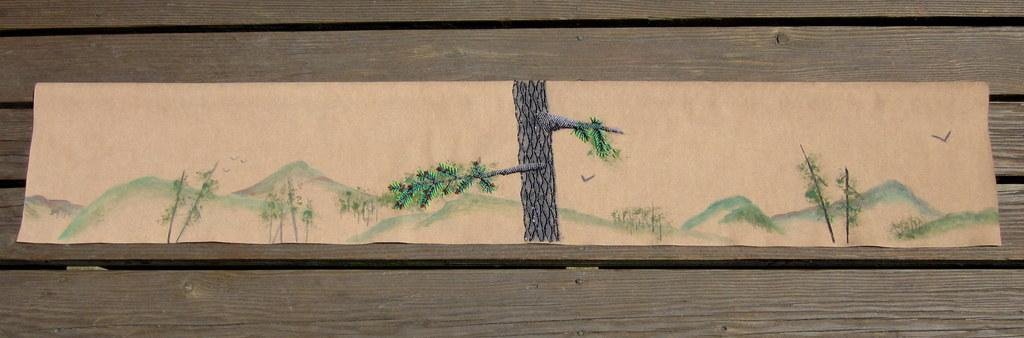What is depicted on the paper in the image? The paper has a painting on it. What is the surface of the painting on? The painting is on a wooden surface. How many brothers are playing on the playground in the image? There is no playground or brothers present in the image; it features a paper with a painting on a wooden surface. 